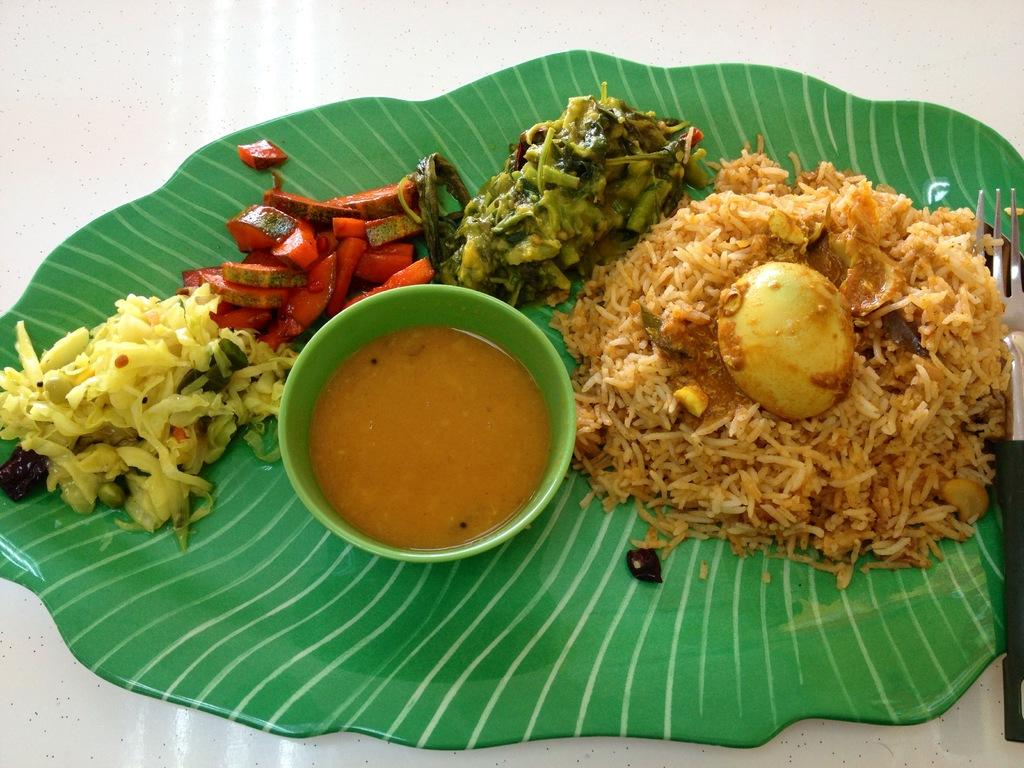What type of items can be seen in the image? There are food items in the image. What utensil is present in the image? There is a fork in the image. What is in the bowl that is visible in the image? There is a bowl with a liquid in the image. How is the bowl positioned in relation to other objects? The bowl is on a plate in the image. What is the plate resting on in the image? The plate is on an object in the image. What type of business is being conducted in the image? There is no indication of a business being conducted in the image; it primarily features food items and related objects. 